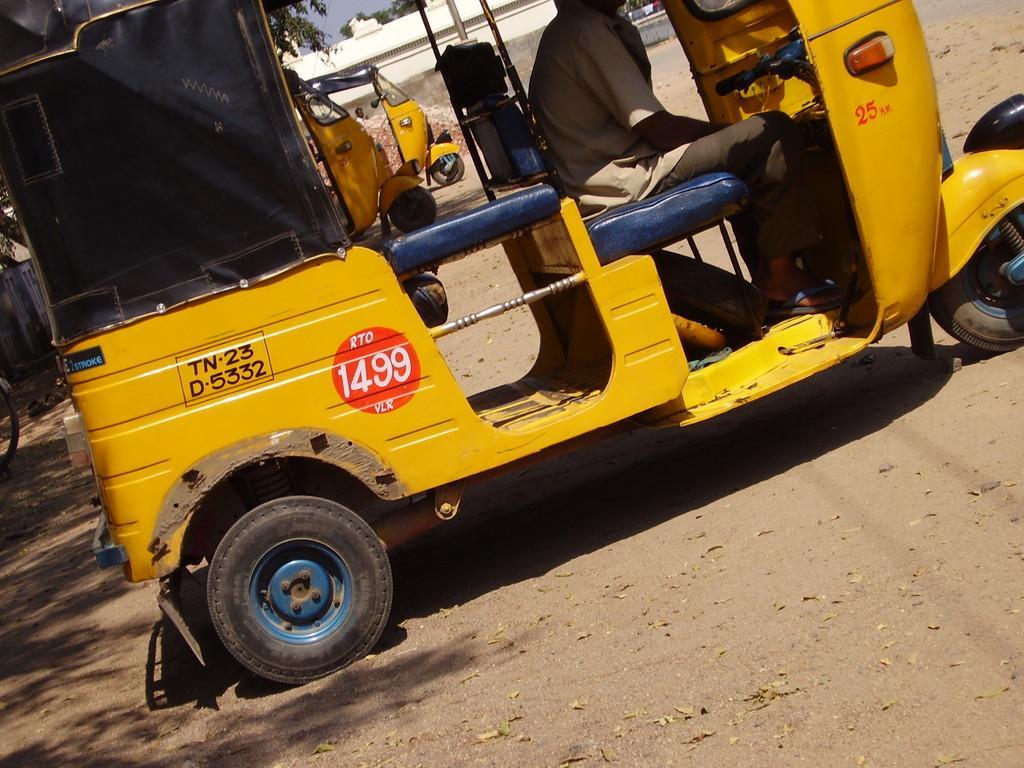Could you give a brief overview of what you see in this image? In this picture we can see vehicles on the ground, here we can see a person and in the background we can see a building, trees, sky. 